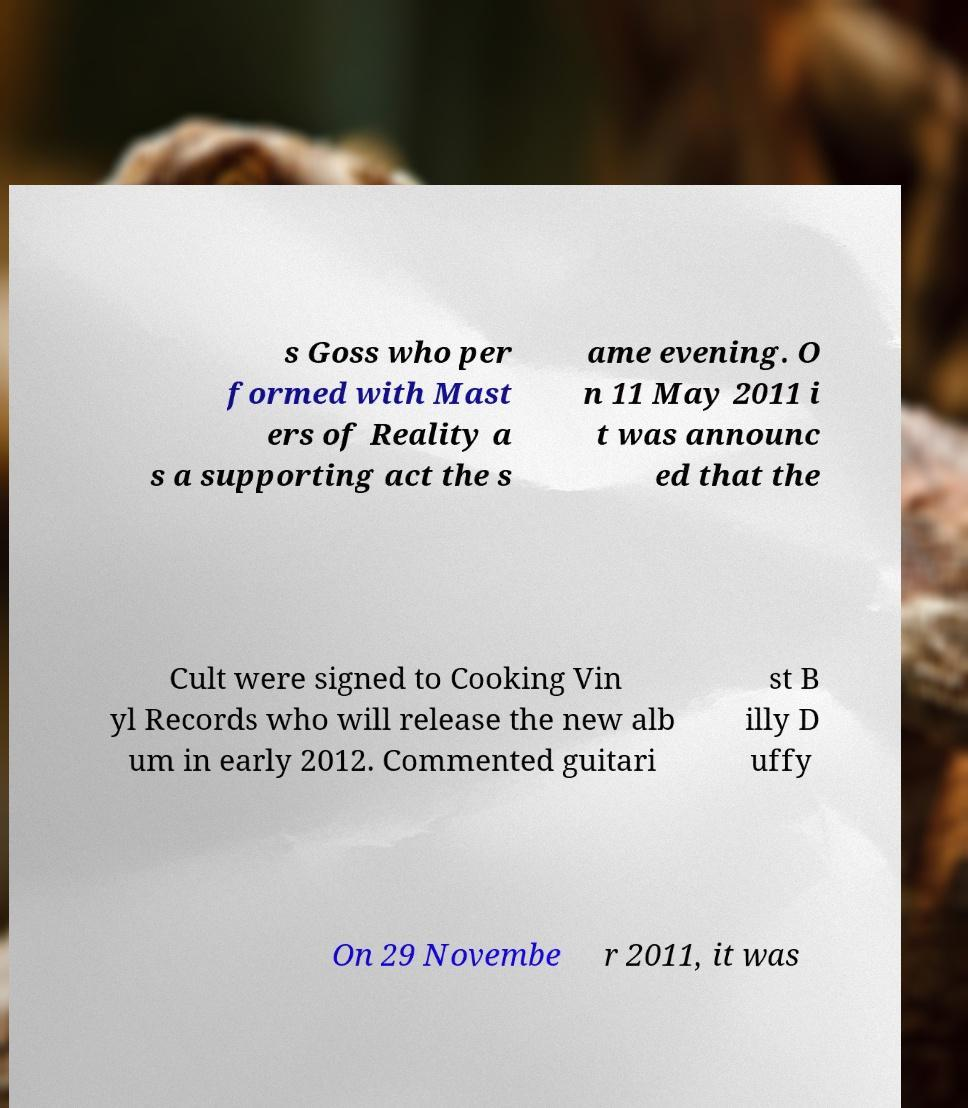What messages or text are displayed in this image? I need them in a readable, typed format. s Goss who per formed with Mast ers of Reality a s a supporting act the s ame evening. O n 11 May 2011 i t was announc ed that the Cult were signed to Cooking Vin yl Records who will release the new alb um in early 2012. Commented guitari st B illy D uffy On 29 Novembe r 2011, it was 